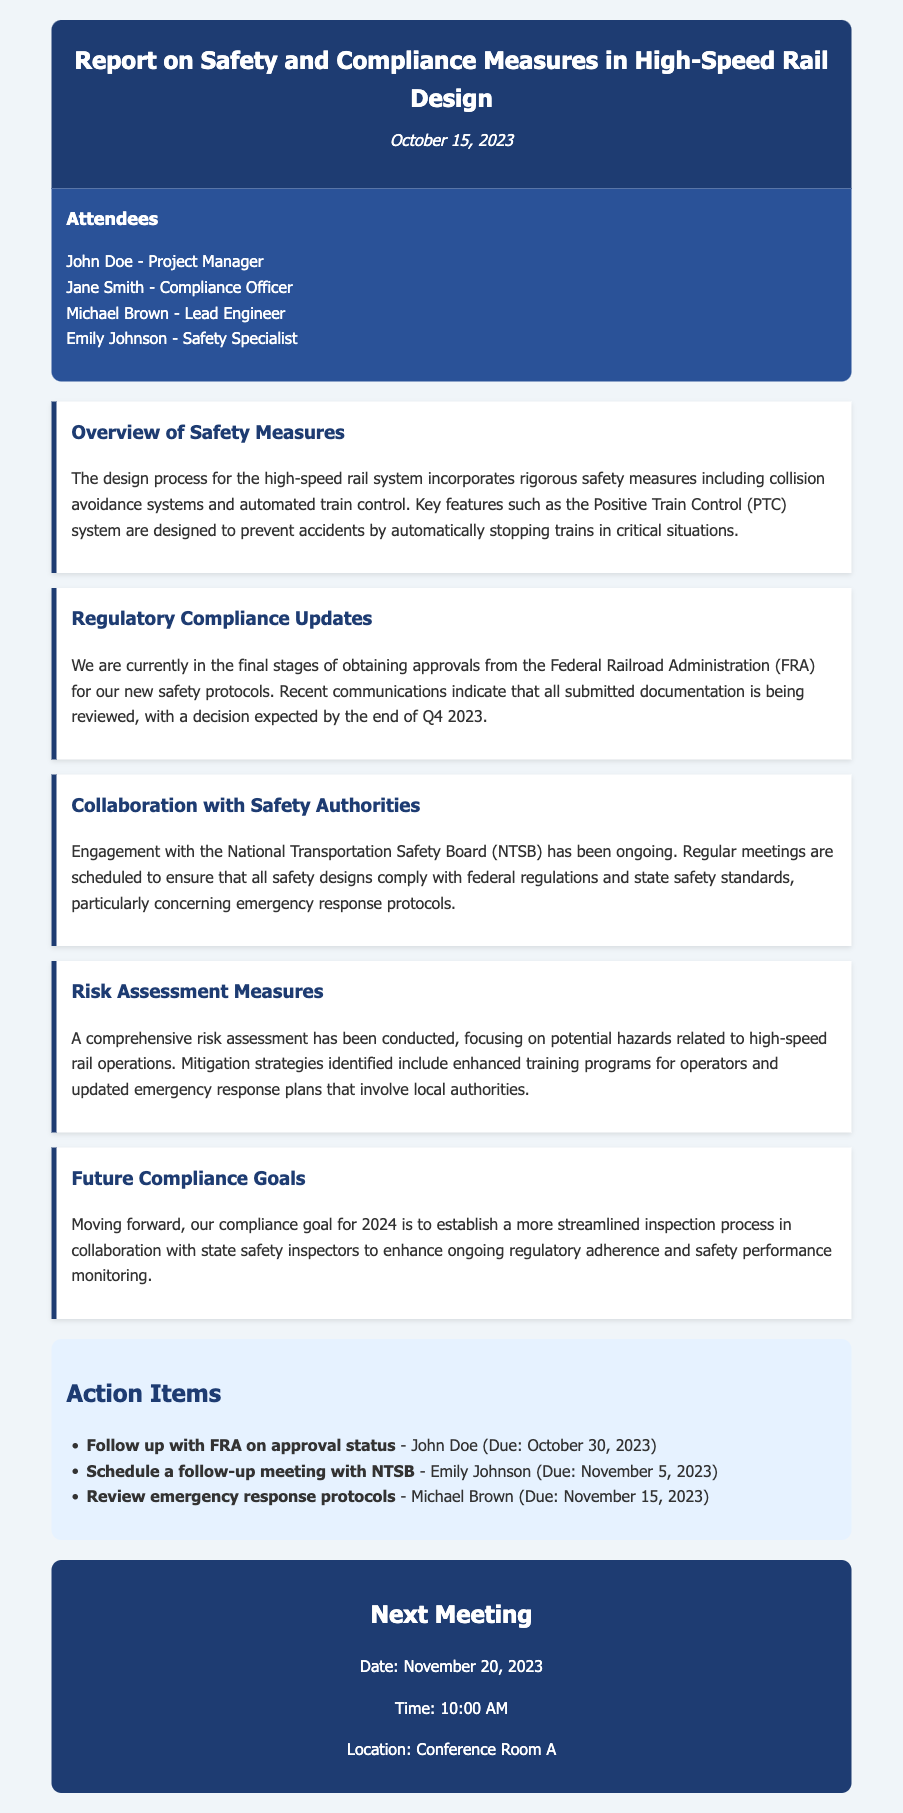What is the date of the meeting? The meeting date is mentioned at the top of the document under the header section.
Answer: October 15, 2023 Who is the Compliance Officer? The attendees section lists the names and titles of all meeting participants.
Answer: Jane Smith What system is designed to prevent accidents? The overview of safety measures describes the key features in the design process, specifically mentioning a system aimed at accident prevention.
Answer: Positive Train Control What is the expected decision date from the FRA? The regulatory compliance updates indicate when a decision regarding approvals is expected.
Answer: End of Q4 2023 Who is scheduled to follow up with the FRA on approval status? The action items section specifies who is responsible for each task and their respective deadlines.
Answer: John Doe What is the compliance goal for 2024? The future compliance goals explicitly outlines the goal for the upcoming year.
Answer: Streamlined inspection process How often are meetings with the NTSB scheduled? The document mentions regularity in meetings with the NTSB, indicating ongoing engagement.
Answer: Regular meetings What is the due date for reviewing emergency response protocols? The action items provide specific due dates next to each task listed.
Answer: November 15, 2023 